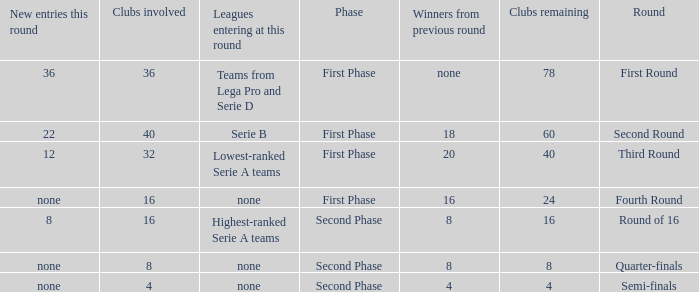During the first phase portion of phase and having 16 clubs involved; what would you find for the winners from previous round? 16.0. Could you help me parse every detail presented in this table? {'header': ['New entries this round', 'Clubs involved', 'Leagues entering at this round', 'Phase', 'Winners from previous round', 'Clubs remaining', 'Round'], 'rows': [['36', '36', 'Teams from Lega Pro and Serie D', 'First Phase', 'none', '78', 'First Round'], ['22', '40', 'Serie B', 'First Phase', '18', '60', 'Second Round'], ['12', '32', 'Lowest-ranked Serie A teams', 'First Phase', '20', '40', 'Third Round'], ['none', '16', 'none', 'First Phase', '16', '24', 'Fourth Round'], ['8', '16', 'Highest-ranked Serie A teams', 'Second Phase', '8', '16', 'Round of 16'], ['none', '8', 'none', 'Second Phase', '8', '8', 'Quarter-finals'], ['none', '4', 'none', 'Second Phase', '4', '4', 'Semi-finals']]} 